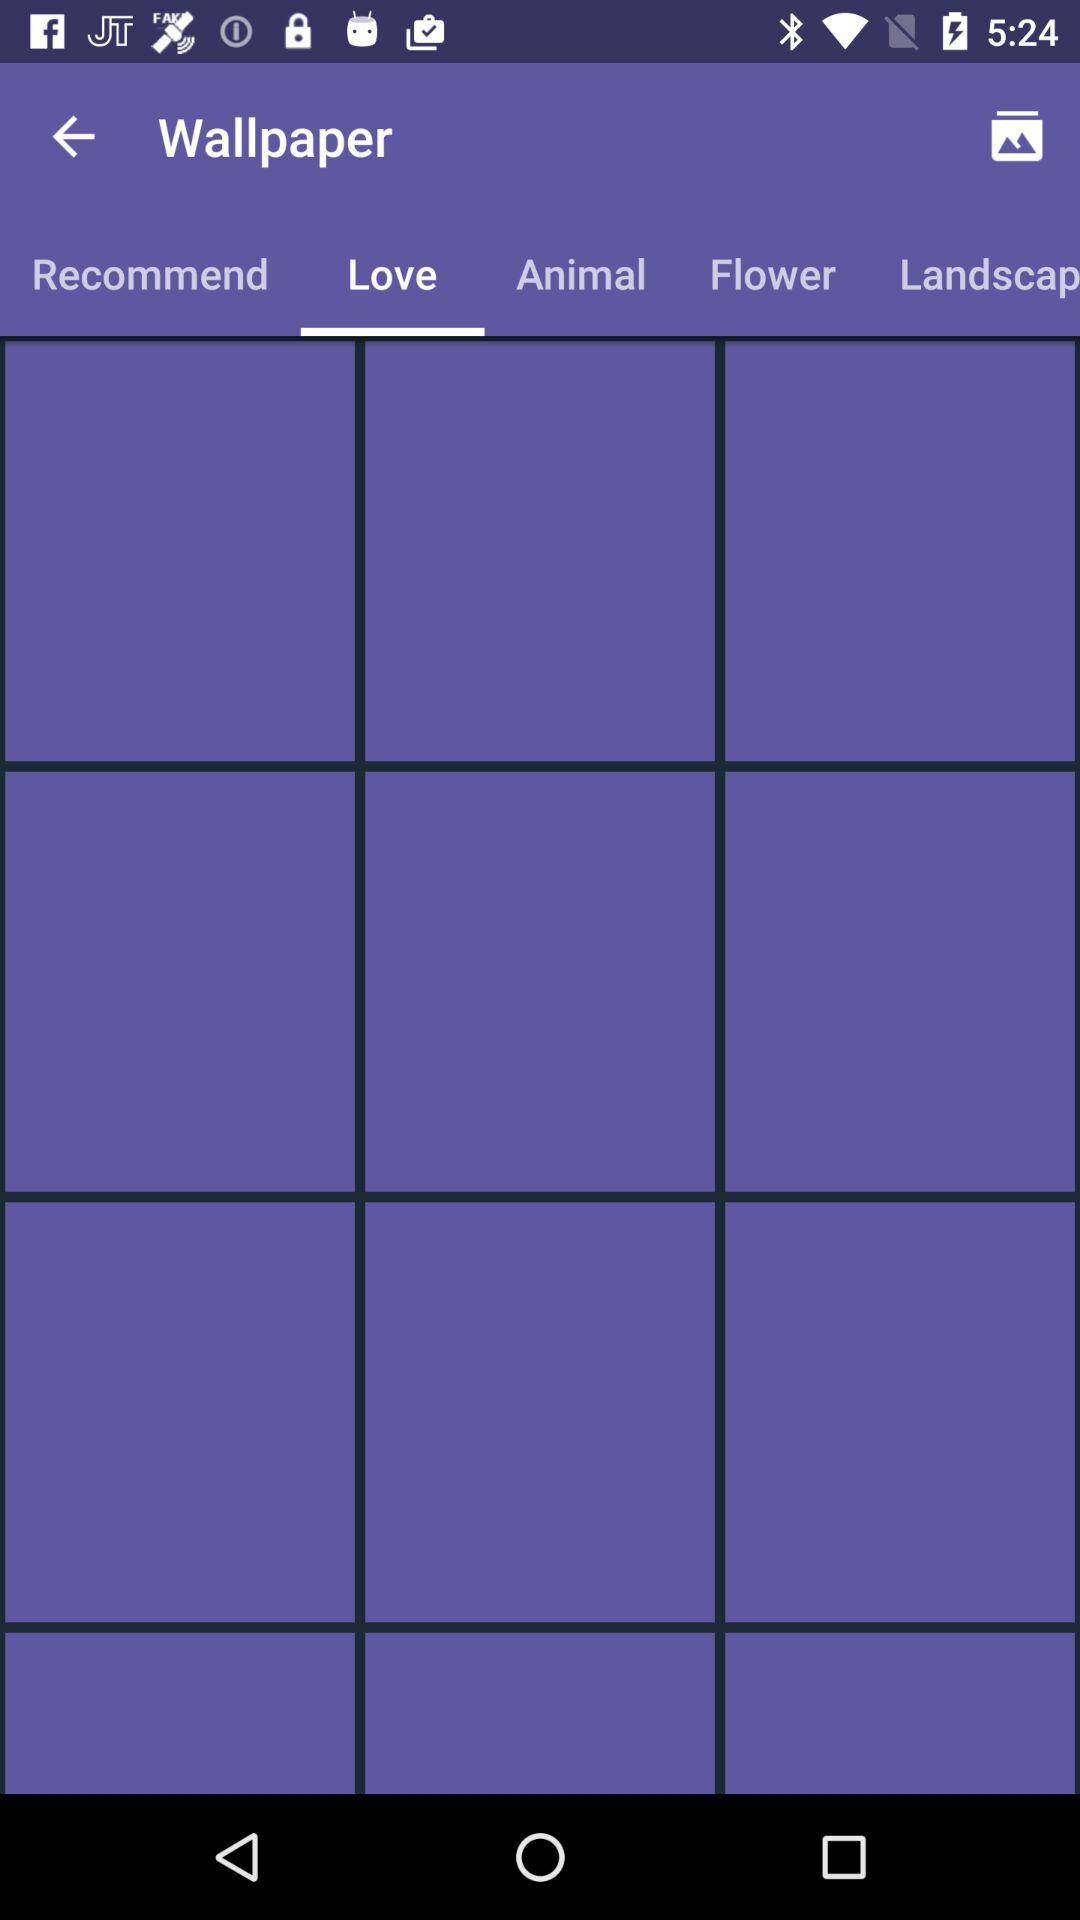Which option is selected in "Wallpaper"? The selected option is "Love". 